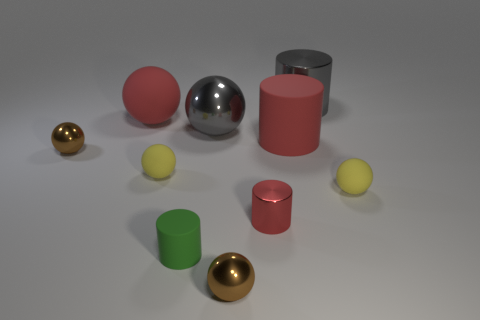Subtract all brown balls. How many balls are left? 4 Subtract all tiny brown metallic balls. How many balls are left? 4 Subtract all purple balls. Subtract all purple blocks. How many balls are left? 6 Subtract all balls. How many objects are left? 4 Subtract 0 brown cylinders. How many objects are left? 10 Subtract all gray balls. Subtract all tiny brown metallic things. How many objects are left? 7 Add 3 tiny balls. How many tiny balls are left? 7 Add 2 green cylinders. How many green cylinders exist? 3 